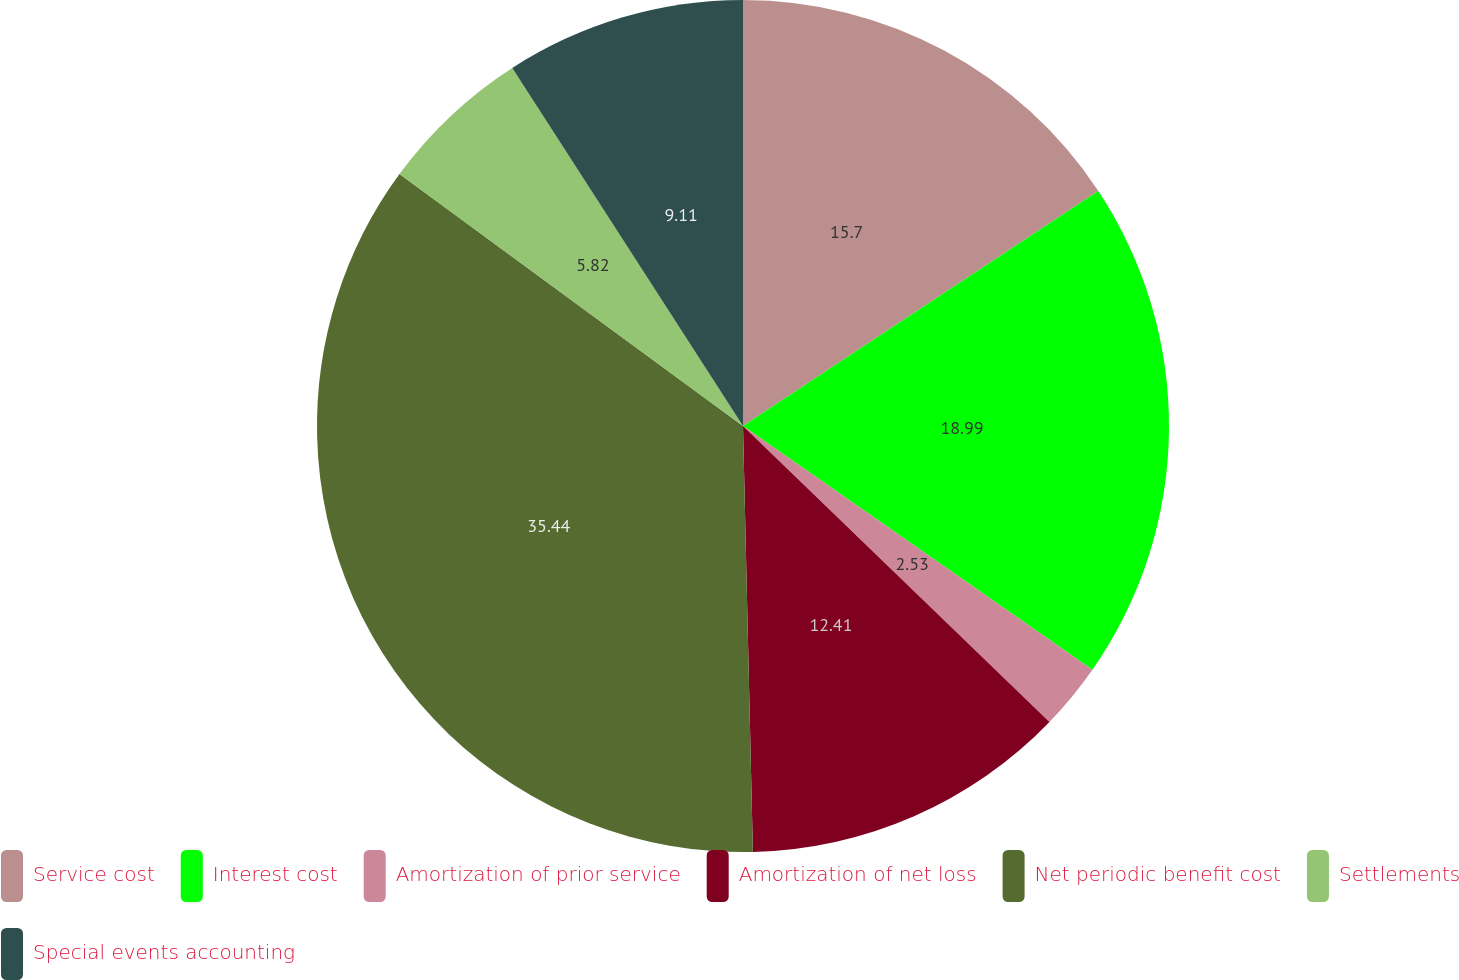<chart> <loc_0><loc_0><loc_500><loc_500><pie_chart><fcel>Service cost<fcel>Interest cost<fcel>Amortization of prior service<fcel>Amortization of net loss<fcel>Net periodic benefit cost<fcel>Settlements<fcel>Special events accounting<nl><fcel>15.7%<fcel>18.99%<fcel>2.53%<fcel>12.41%<fcel>35.44%<fcel>5.82%<fcel>9.11%<nl></chart> 